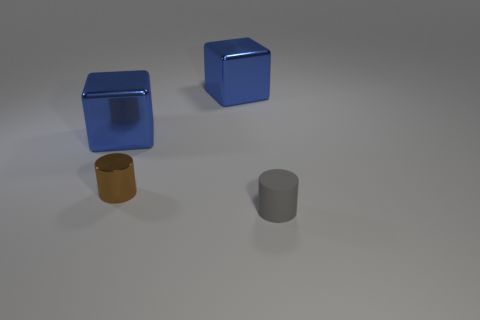Add 4 small cylinders. How many objects exist? 8 Subtract 0 gray cubes. How many objects are left? 4 Subtract all small yellow objects. Subtract all tiny gray matte things. How many objects are left? 3 Add 2 brown cylinders. How many brown cylinders are left? 3 Add 1 tiny gray rubber cylinders. How many tiny gray rubber cylinders exist? 2 